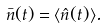<formula> <loc_0><loc_0><loc_500><loc_500>\bar { n } ( t ) = \langle \hat { n } ( t ) \rangle .</formula> 